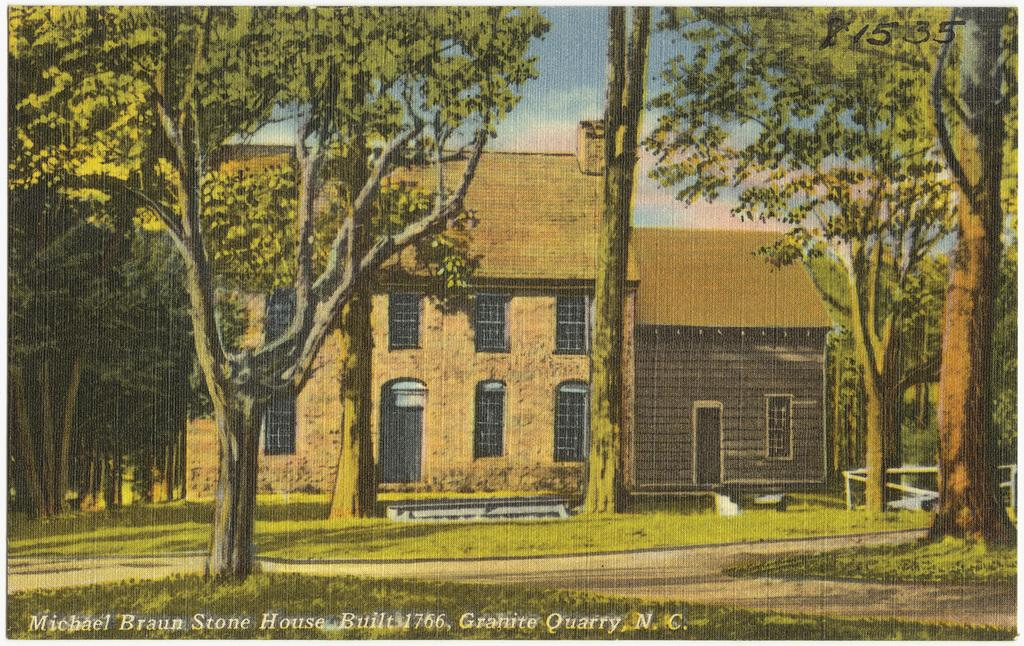What is the main subject of the poster in the image? The poster depicts a house. What features can be seen on the house? The house has windows. What type of vegetation is in front of the house? There are trees in front of the house. What is visible at the bottom of the image? There is grass at the bottom of the image. What is visible at the top of the image? The sky is visible at the top of the image. What word is written on the shirt of the person standing next to the house in the image? There is no person or shirt present in the image; it only contains a poster with a house, trees, grass, and the sky. 